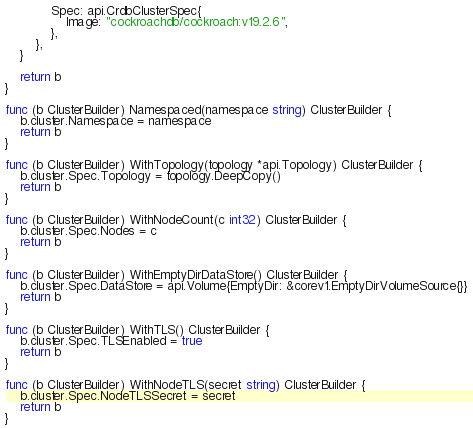Convert code to text. <code><loc_0><loc_0><loc_500><loc_500><_Go_>			Spec: api.CrdbClusterSpec{
				Image: "cockroachdb/cockroach:v19.2.6",
			},
		},
	}

	return b
}

func (b ClusterBuilder) Namespaced(namespace string) ClusterBuilder {
	b.cluster.Namespace = namespace
	return b
}

func (b ClusterBuilder) WithTopology(topology *api.Topology) ClusterBuilder {
	b.cluster.Spec.Topology = topology.DeepCopy()
	return b
}

func (b ClusterBuilder) WithNodeCount(c int32) ClusterBuilder {
	b.cluster.Spec.Nodes = c
	return b
}

func (b ClusterBuilder) WithEmptyDirDataStore() ClusterBuilder {
	b.cluster.Spec.DataStore = api.Volume{EmptyDir: &corev1.EmptyDirVolumeSource{}}
	return b
}

func (b ClusterBuilder) WithTLS() ClusterBuilder {
	b.cluster.Spec.TLSEnabled = true
	return b
}

func (b ClusterBuilder) WithNodeTLS(secret string) ClusterBuilder {
	b.cluster.Spec.NodeTLSSecret = secret
	return b
}
</code> 